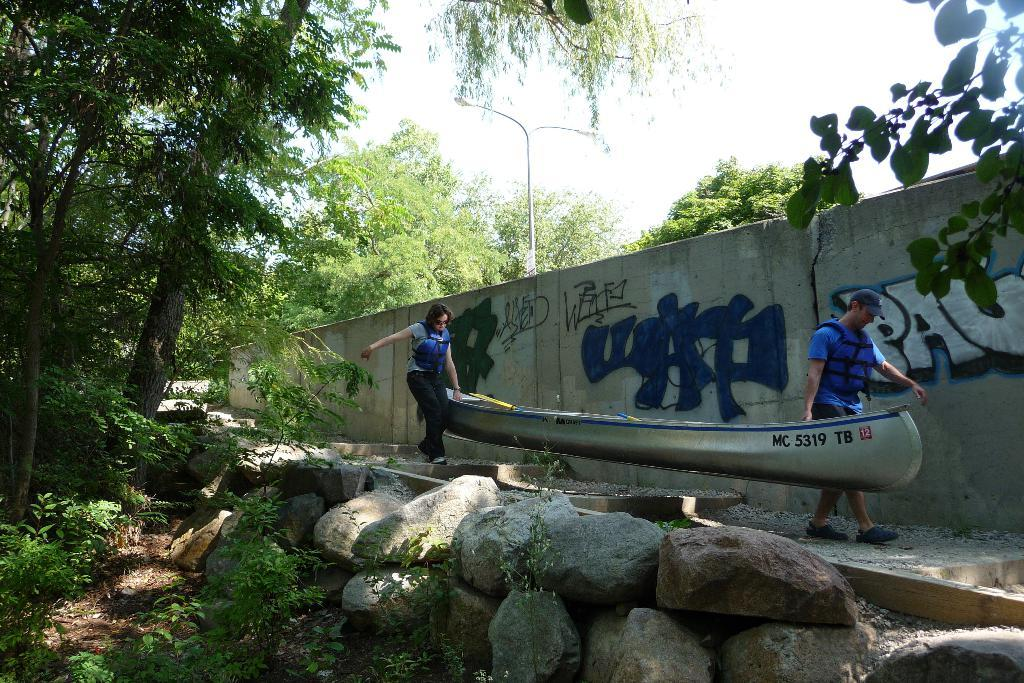How many people are in the image? There are two persons in the image. What are the persons holding in the image? The persons are holding a boat. What safety equipment are the persons wearing? The persons are wearing life jackets. What type of natural features can be seen in the image? There are rocks, plants, and trees in the image. What man-made structure is present in the image? There is a street light pole in the image. What part of the natural environment is visible in the image? The sky is visible in the image. What word is written on the nest in the image? There is no nest present in the image, so it is not possible to determine if any word is written on it. 